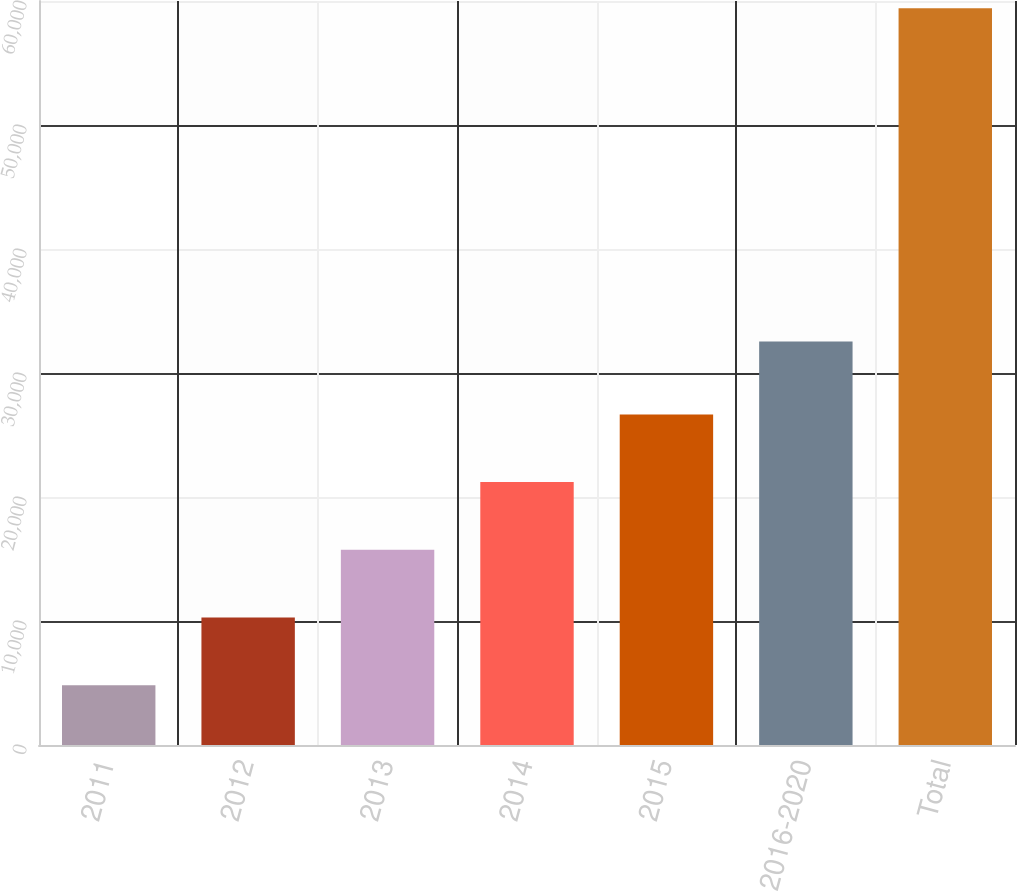<chart> <loc_0><loc_0><loc_500><loc_500><bar_chart><fcel>2011<fcel>2012<fcel>2013<fcel>2014<fcel>2015<fcel>2016-2020<fcel>Total<nl><fcel>4822<fcel>10282.2<fcel>15742.4<fcel>21202.6<fcel>26662.8<fcel>32534<fcel>59424<nl></chart> 